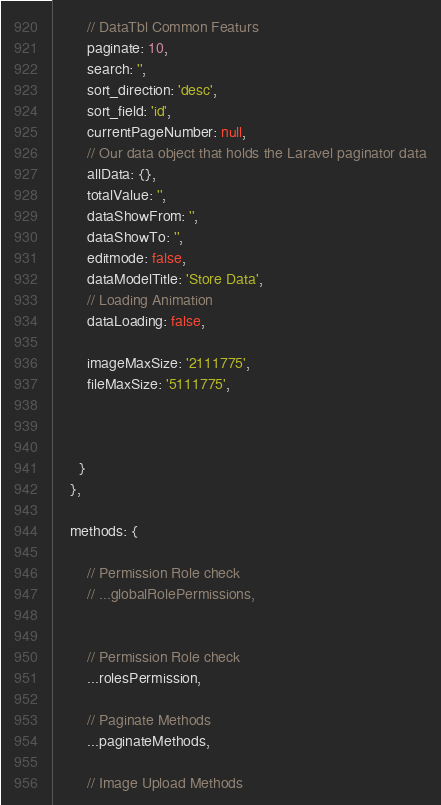Convert code to text. <code><loc_0><loc_0><loc_500><loc_500><_JavaScript_>        // DataTbl Common Featurs 
        paginate: 10,
        search: '',
        sort_direction: 'desc',
        sort_field: 'id',
        currentPageNumber: null,
        // Our data object that holds the Laravel paginator data
        allData: {},
        totalValue: '',
        dataShowFrom: '',
        dataShowTo: '',
        editmode: false,
        dataModelTitle: 'Store Data',
        // Loading Animation
        dataLoading: false,

        imageMaxSize: '2111775',
        fileMaxSize: '5111775',

       

      }
    },

    methods: {

        // Permission Role check
        // ...globalRolePermissions,

        
        // Permission Role check
        ...rolesPermission,
      
        // Paginate Methods
        ...paginateMethods,

        // Image Upload Methods</code> 